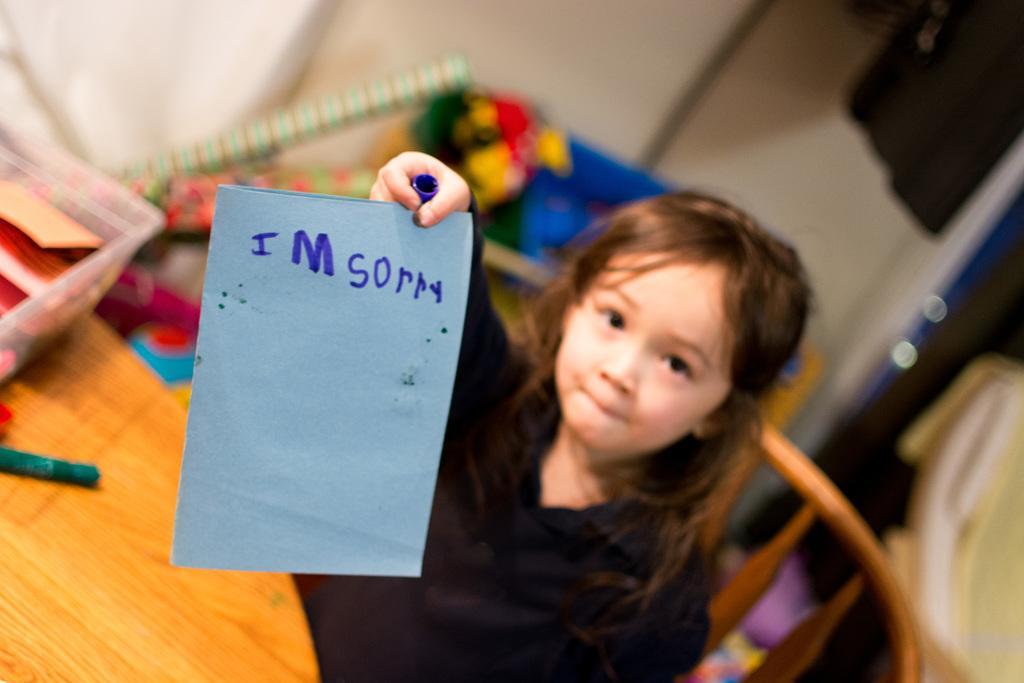How would you summarize this image in a sentence or two? In this picture, we see a girl in the black dress is sitting on the chair and she is holding a blue color card with text written as "I m sorry". In front of her, we see a table on which a plastic box containing the cards and a green color objects are placed. Behind her, we see the objects in blue, green, yellow and pink color. On the right side, we see a cloth in white and yellow color. Behind that, we see a violet color toy. In the background, we see a wall. In the right top, we see an object in black color. This picture is blurred in the background. 